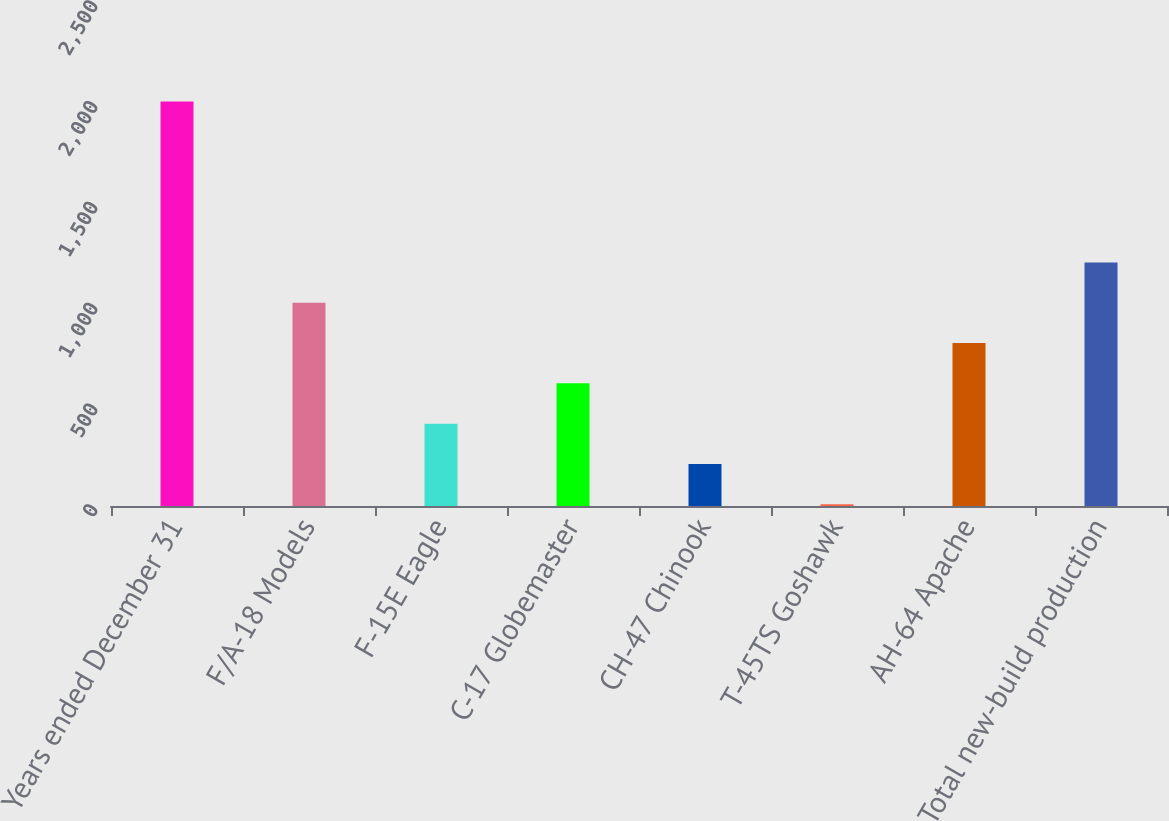Convert chart. <chart><loc_0><loc_0><loc_500><loc_500><bar_chart><fcel>Years ended December 31<fcel>F/A-18 Models<fcel>F-15E Eagle<fcel>C-17 Globemaster<fcel>CH-47 Chinook<fcel>T-45TS Goshawk<fcel>AH-64 Apache<fcel>Total new-build production<nl><fcel>2007<fcel>1008<fcel>408.6<fcel>608.4<fcel>208.8<fcel>9<fcel>808.2<fcel>1207.8<nl></chart> 